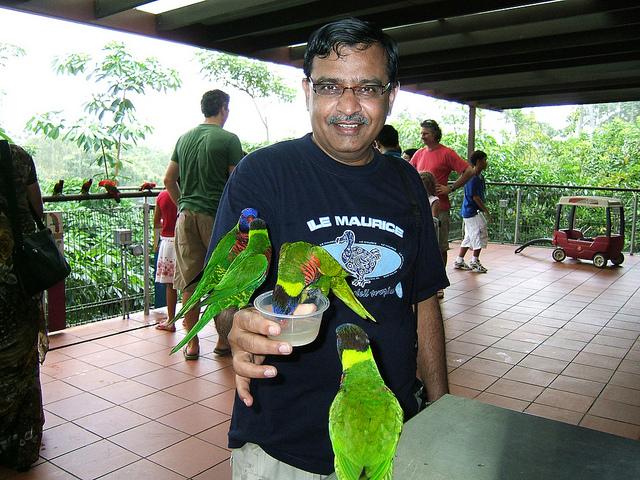How many birds are there in the picture?
Keep it brief. 4. I can see four of what bird?
Short answer required. Parrot. What color are the birds?
Keep it brief. Green. 